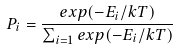Convert formula to latex. <formula><loc_0><loc_0><loc_500><loc_500>P _ { i } = \frac { e x p ( - E _ { i } / k T ) } { \sum _ { i = 1 } e x p ( - E _ { i } / k T ) }</formula> 